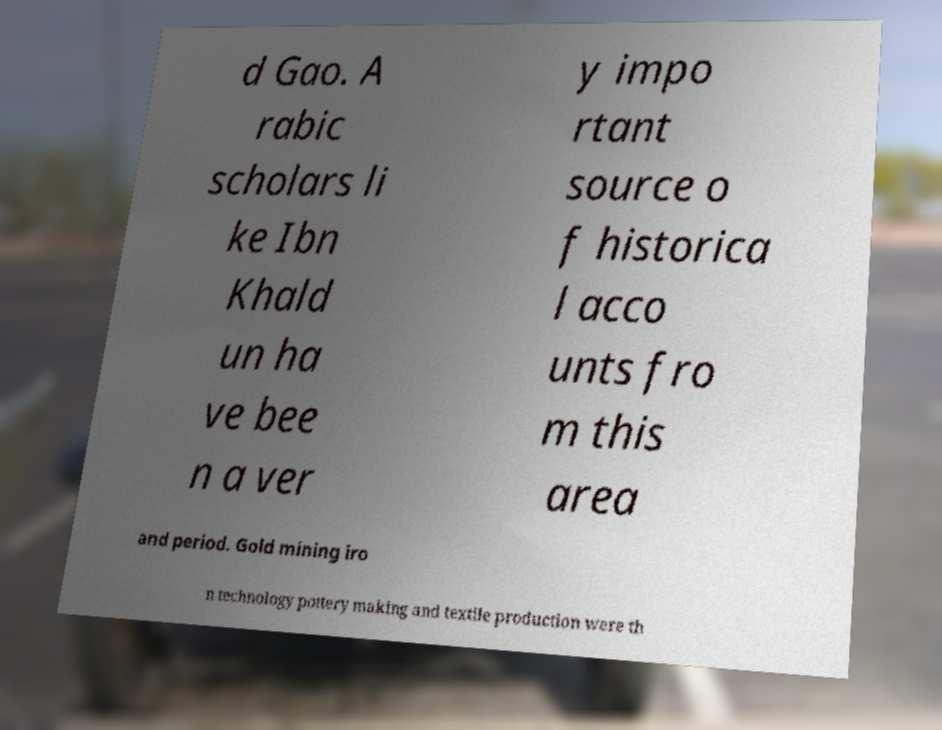Please identify and transcribe the text found in this image. d Gao. A rabic scholars li ke Ibn Khald un ha ve bee n a ver y impo rtant source o f historica l acco unts fro m this area and period. Gold mining iro n technology pottery making and textile production were th 